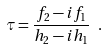Convert formula to latex. <formula><loc_0><loc_0><loc_500><loc_500>\tau = \frac { f _ { 2 } - i f _ { 1 } } { h _ { 2 } - i h _ { 1 } } \ .</formula> 